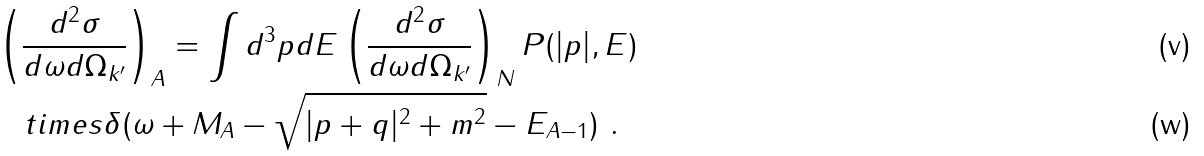Convert formula to latex. <formula><loc_0><loc_0><loc_500><loc_500>& \left ( \frac { d ^ { 2 } \sigma } { d \omega d \Omega _ { k ^ { \prime } } } \right ) _ { A } = \int d ^ { 3 } p d E \left ( \frac { d ^ { 2 } \sigma } { d \omega d \Omega _ { k ^ { \prime } } } \right ) _ { N } P ( | { p } | , E ) \\ & \quad t i m e s \delta ( \omega + M _ { A } - \sqrt { | { p } + { q } | ^ { 2 } + m ^ { 2 } } - E _ { A - 1 } ) \ .</formula> 